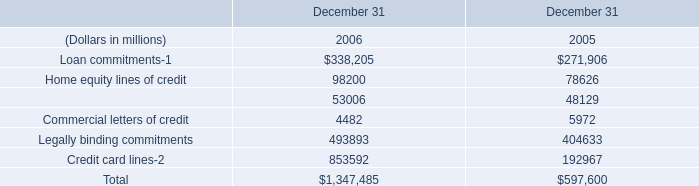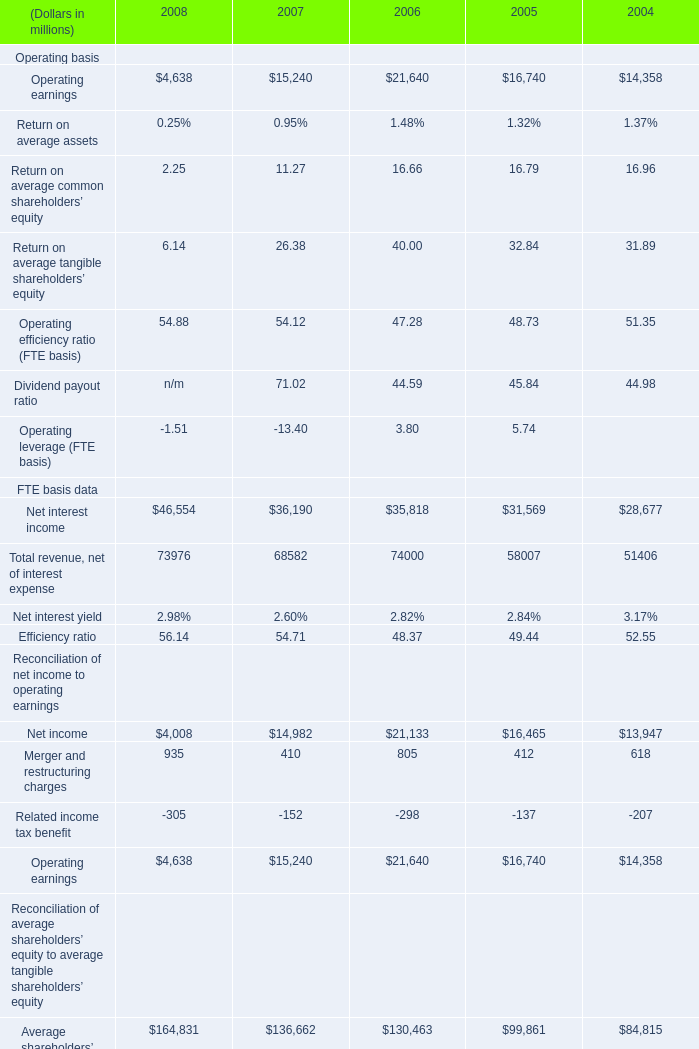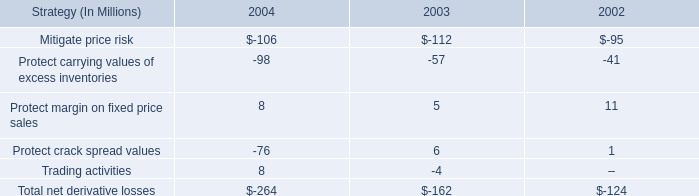What is the average amount of Legally binding commitments of December 31 2005, and Operating earnings of 2008 ? 
Computations: ((404633.0 + 4638.0) / 2)
Answer: 204635.5. 